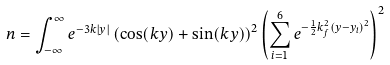<formula> <loc_0><loc_0><loc_500><loc_500>n = \int _ { - \infty } ^ { \infty } e ^ { - 3 k | y | } \left ( \cos ( k y ) + \sin ( k y ) \right ) ^ { 2 } \left ( \sum _ { i = 1 } ^ { 6 } e ^ { - \frac { 1 } { 2 } k _ { f } ^ { 2 } ( y - y _ { i } ) ^ { 2 } } \right ) ^ { 2 }</formula> 